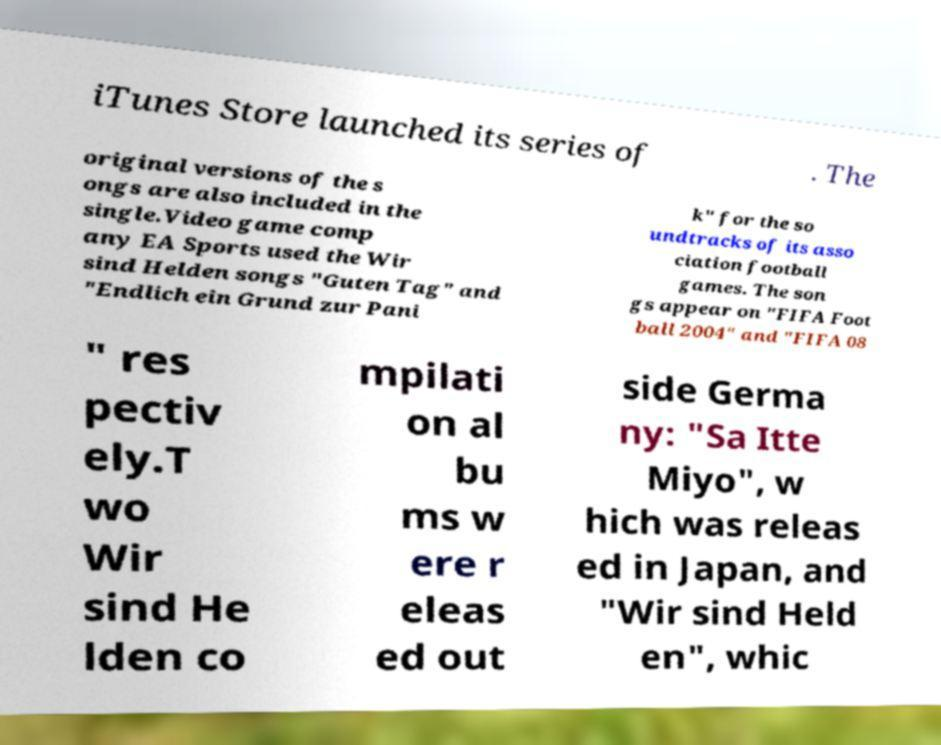There's text embedded in this image that I need extracted. Can you transcribe it verbatim? iTunes Store launched its series of . The original versions of the s ongs are also included in the single.Video game comp any EA Sports used the Wir sind Helden songs "Guten Tag" and "Endlich ein Grund zur Pani k" for the so undtracks of its asso ciation football games. The son gs appear on "FIFA Foot ball 2004" and "FIFA 08 " res pectiv ely.T wo Wir sind He lden co mpilati on al bu ms w ere r eleas ed out side Germa ny: "Sa Itte Miyo", w hich was releas ed in Japan, and "Wir sind Held en", whic 